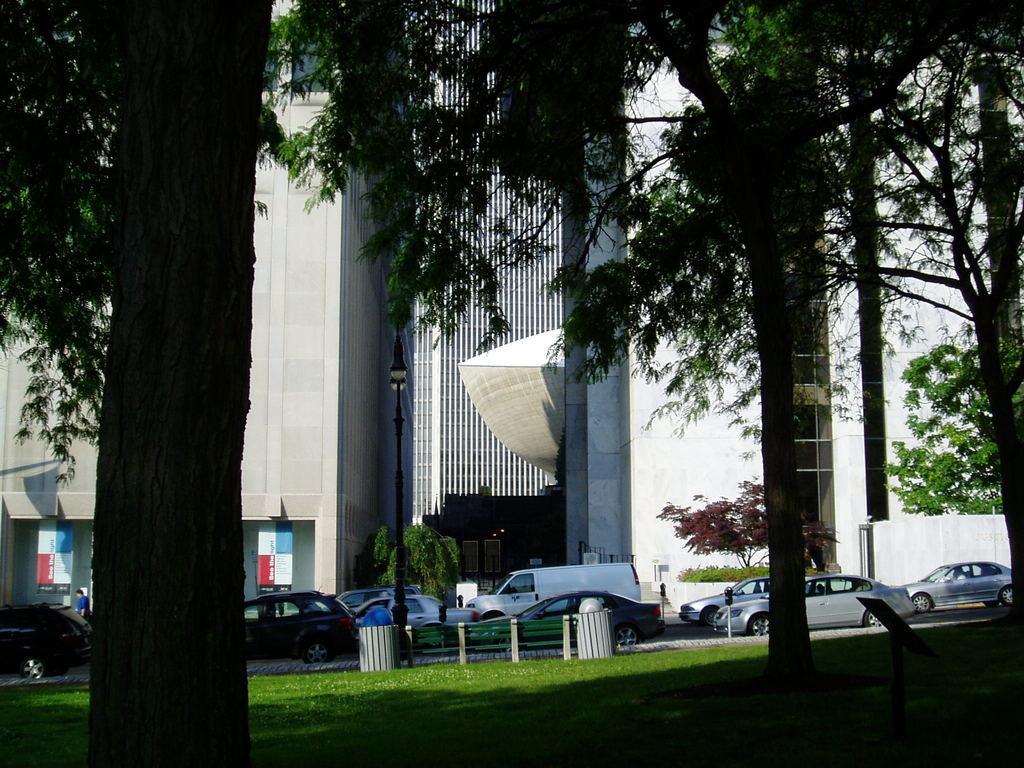Please provide a concise description of this image. In the center of the image we can see group of vehicles parked on the road,a light pole ,two trash bins. In the background ,we can see group of trees ,buildings. 